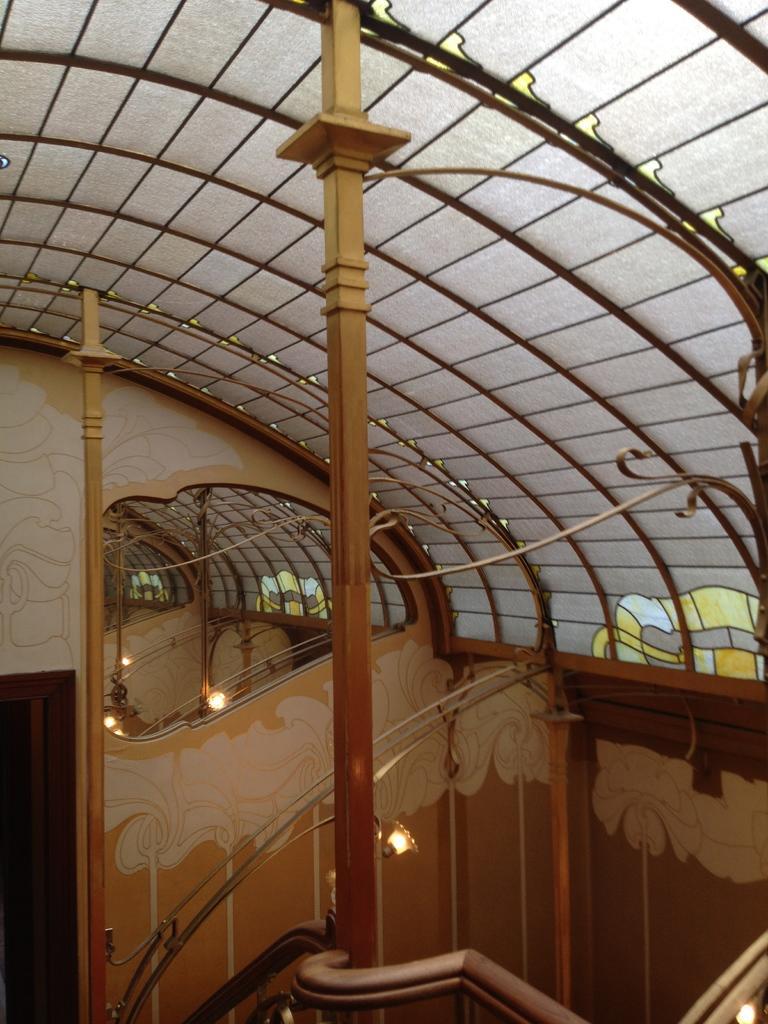Describe this image in one or two sentences. In this image I can see the inner view of building. 